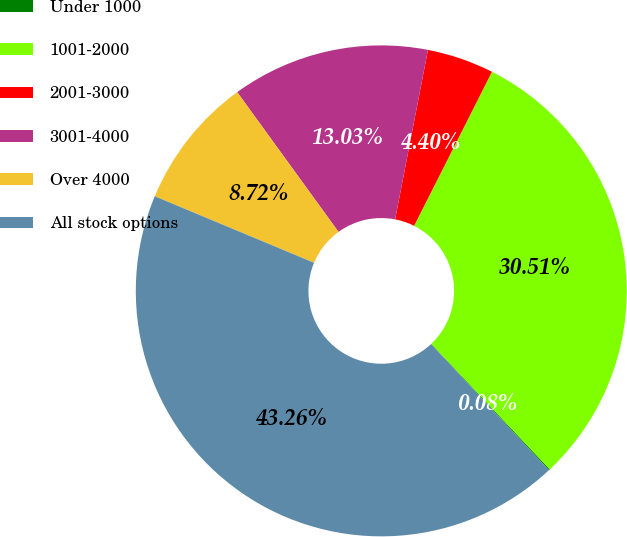Convert chart to OTSL. <chart><loc_0><loc_0><loc_500><loc_500><pie_chart><fcel>Under 1000<fcel>1001-2000<fcel>2001-3000<fcel>3001-4000<fcel>Over 4000<fcel>All stock options<nl><fcel>0.08%<fcel>30.51%<fcel>4.4%<fcel>13.03%<fcel>8.72%<fcel>43.26%<nl></chart> 